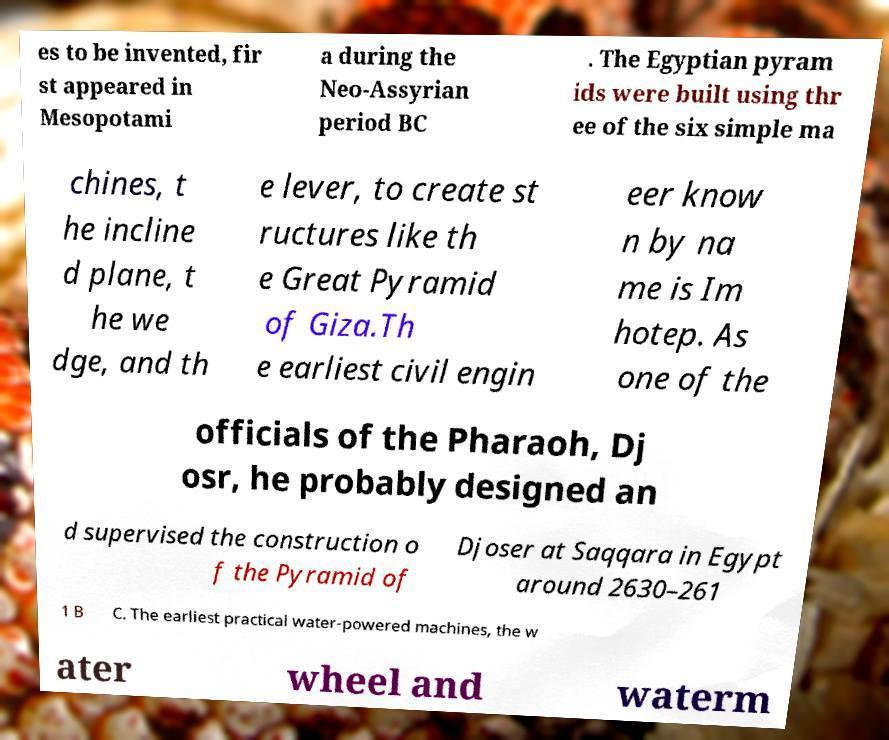Can you read and provide the text displayed in the image?This photo seems to have some interesting text. Can you extract and type it out for me? es to be invented, fir st appeared in Mesopotami a during the Neo-Assyrian period BC . The Egyptian pyram ids were built using thr ee of the six simple ma chines, t he incline d plane, t he we dge, and th e lever, to create st ructures like th e Great Pyramid of Giza.Th e earliest civil engin eer know n by na me is Im hotep. As one of the officials of the Pharaoh, Dj osr, he probably designed an d supervised the construction o f the Pyramid of Djoser at Saqqara in Egypt around 2630–261 1 B C. The earliest practical water-powered machines, the w ater wheel and waterm 